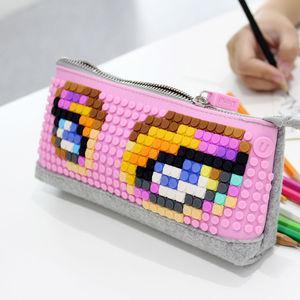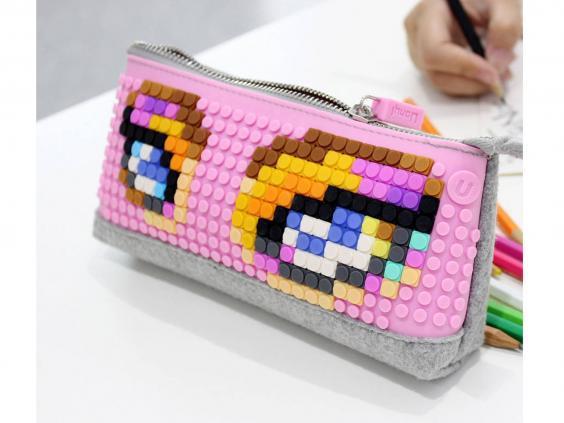The first image is the image on the left, the second image is the image on the right. For the images displayed, is the sentence "At least one pencil case does not use a zipper to close." factually correct? Answer yes or no. No. 